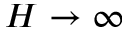<formula> <loc_0><loc_0><loc_500><loc_500>H \rightarrow \infty</formula> 